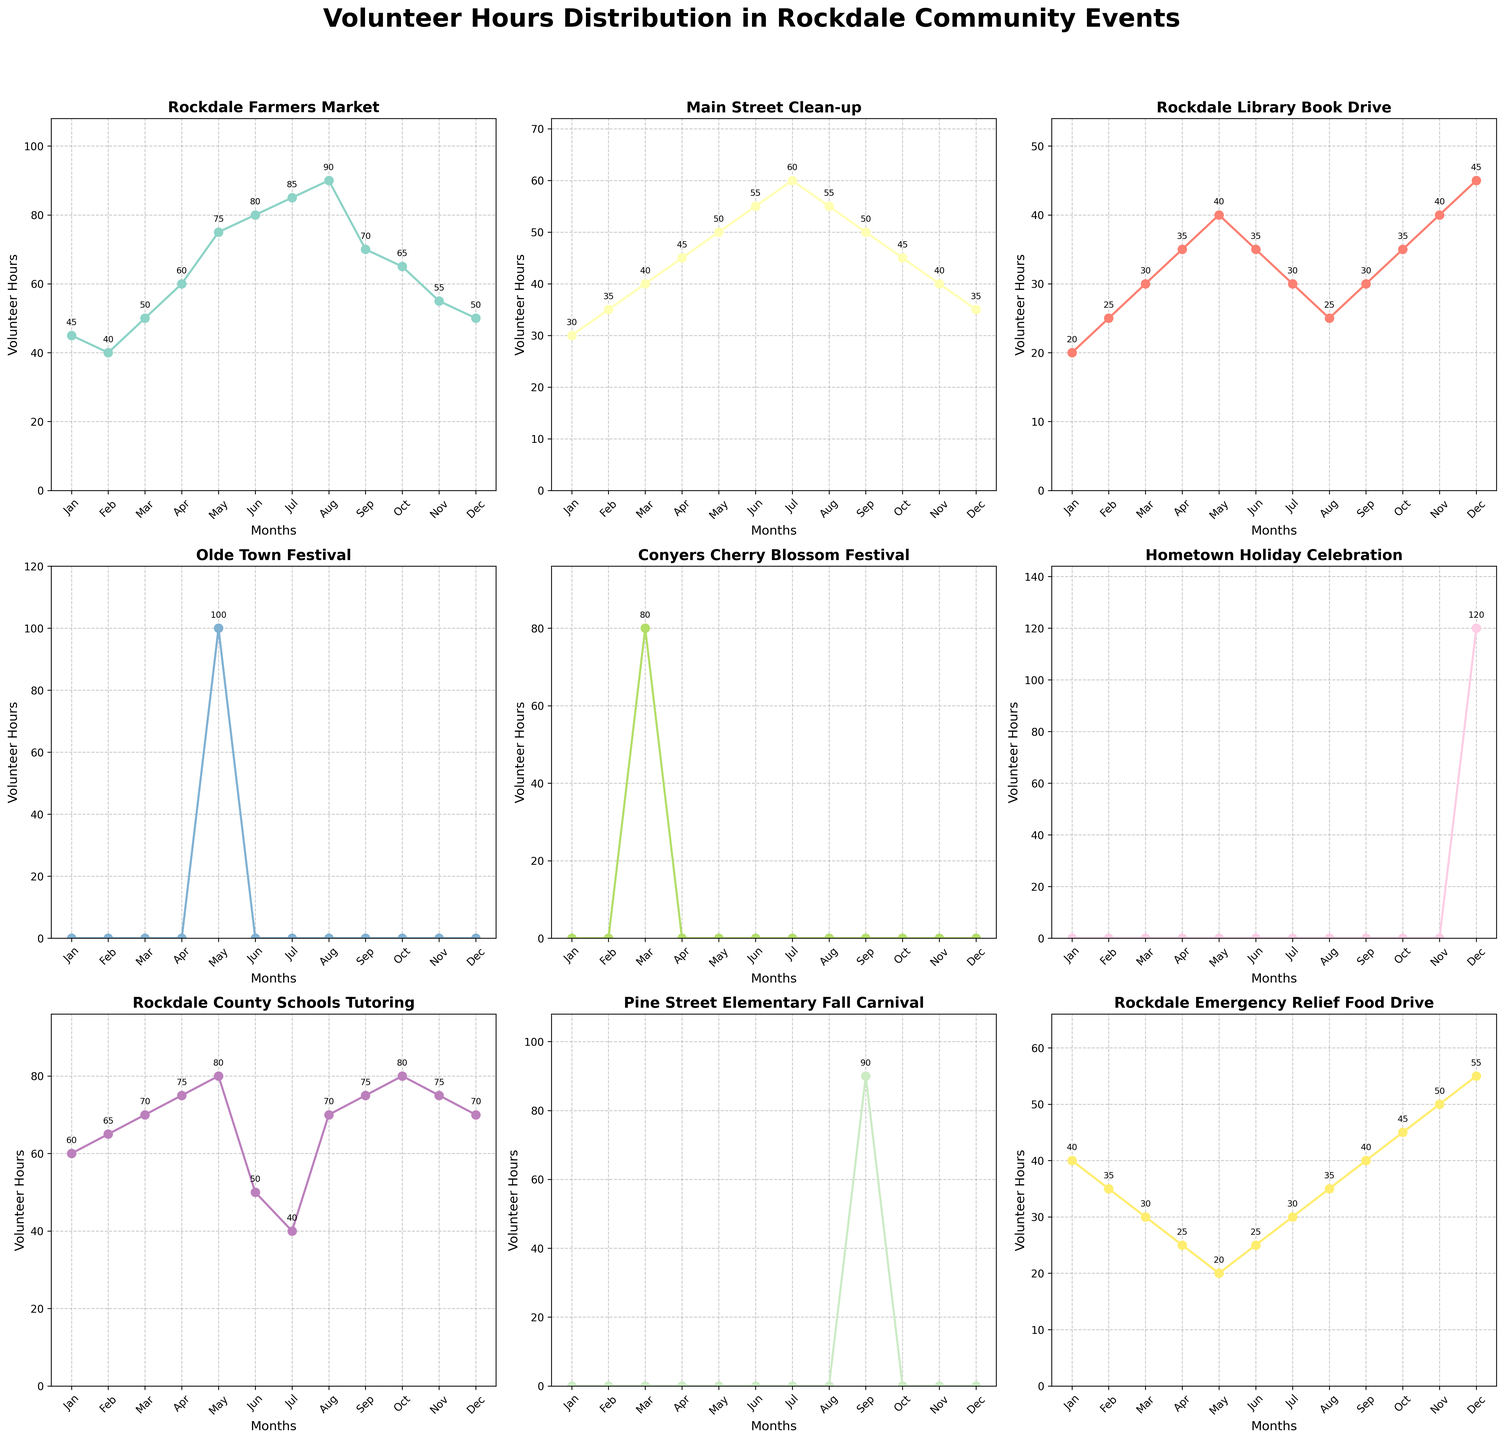What is the title of the figure? Look at the top of the figure where the title is displayed. The title is usually presented in bold and larger font size.
Answer: Volunteer Hours Distribution in Rockdale Community Events Which event has the highest volunteer hours in June? Examine the subplot for each event and identify the one with the highest value on the y-axis for the month of June.
Answer: Rockdale Farmers Market How do the volunteer hours in January for Rockdale Emergency Relief Food Drive compare to those in December? Look at the subplot for Rockdale Emergency Relief Food Drive and compare the values for January and December. January has 40 hours and December has 55 hours.
Answer: January has fewer hours than December What is the average number of volunteer hours for Main Street Clean-up from January to June? Sum the values from January to June (30 + 35 + 40 + 45 + 50 + 55) and then divide by the number of months (6).
Answer: 42.5 In which month does the Hometown Holiday Celebration occur, and how many volunteer hours does it have? Identify the subplot for Hometown Holiday Celebration and see where the value is non-zero. The hours for December are 120.
Answer: December, 120 hours Which event has zero volunteer hours for most of the months? Look at the subplots and identify the events with zero volunteer hours for the majority of the months. Olde Town Festival, Conyers Cherry Blossom Festival, and Pine Street Elementary Fall Carnival have zero hours for most months.
Answer: Olde Town Festival, Conyers Cherry Blossom Festival, and Pine Street Elementary Fall Carnival Compare the volunteer hours for Rockdale County Schools Tutoring between July and August. Which month has higher hours? Look at the subplot for Rockdale County Schools Tutoring and compare the values for July and August. July has 40 hours and August has 70 hours.
Answer: August How many months show volunteer hours for Conyers Cherry Blossom Festival? Check the subplot for Conyers Cherry Blossom Festival and count the number of months with non-zero values. Only March has non-zero hours.
Answer: 1 month What is the sum of volunteer hours for Rockdale Farmers Market in the Summer months (June, July, and August)? Add the values for June, July, and August from the Rockdale Farmers Market subplot (80 + 85 + 90).
Answer: 255 Which event shows a peak in volunteer hours in May? Examine all subplots and find the event with the highest value in the month of May. Rockdale Farmers Market shows a peak in May.
Answer: Rockdale Farmers Market 